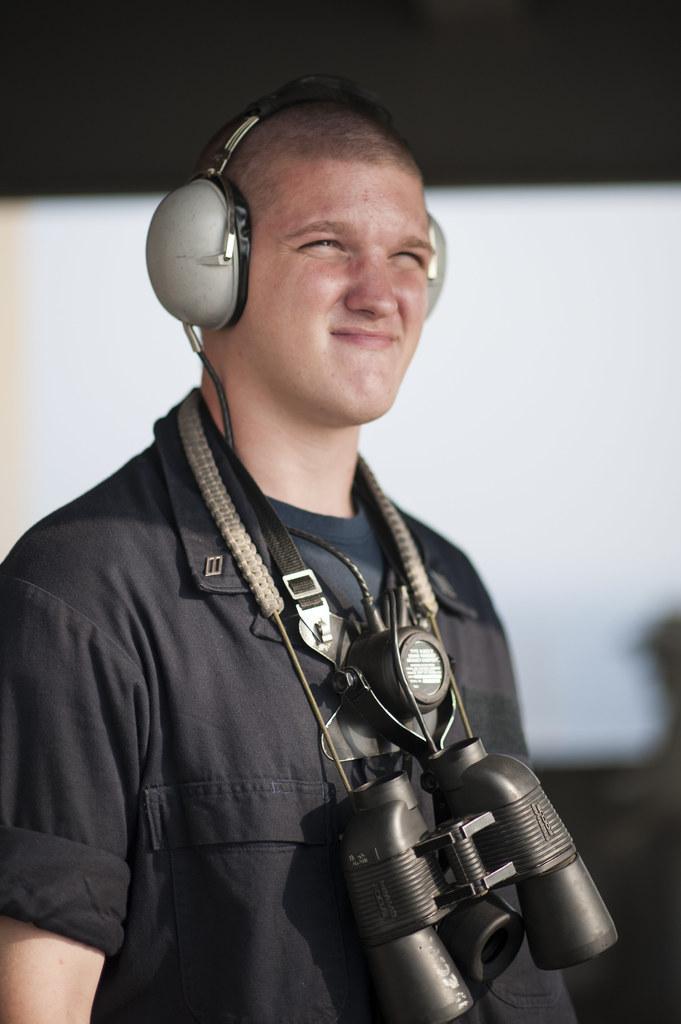In one or two sentences, can you explain what this image depicts? In this picture we can see a person, this person is wearing binoculars and a headset, there is a blurry background. 